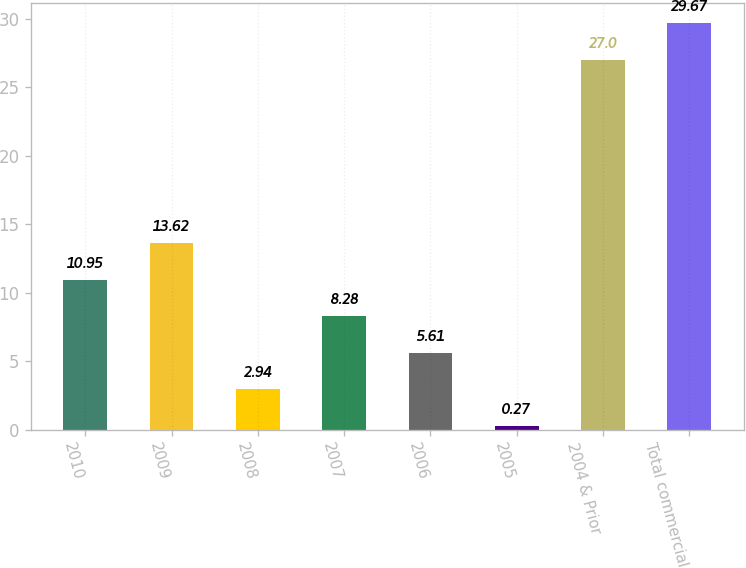<chart> <loc_0><loc_0><loc_500><loc_500><bar_chart><fcel>2010<fcel>2009<fcel>2008<fcel>2007<fcel>2006<fcel>2005<fcel>2004 & Prior<fcel>Total commercial<nl><fcel>10.95<fcel>13.62<fcel>2.94<fcel>8.28<fcel>5.61<fcel>0.27<fcel>27<fcel>29.67<nl></chart> 